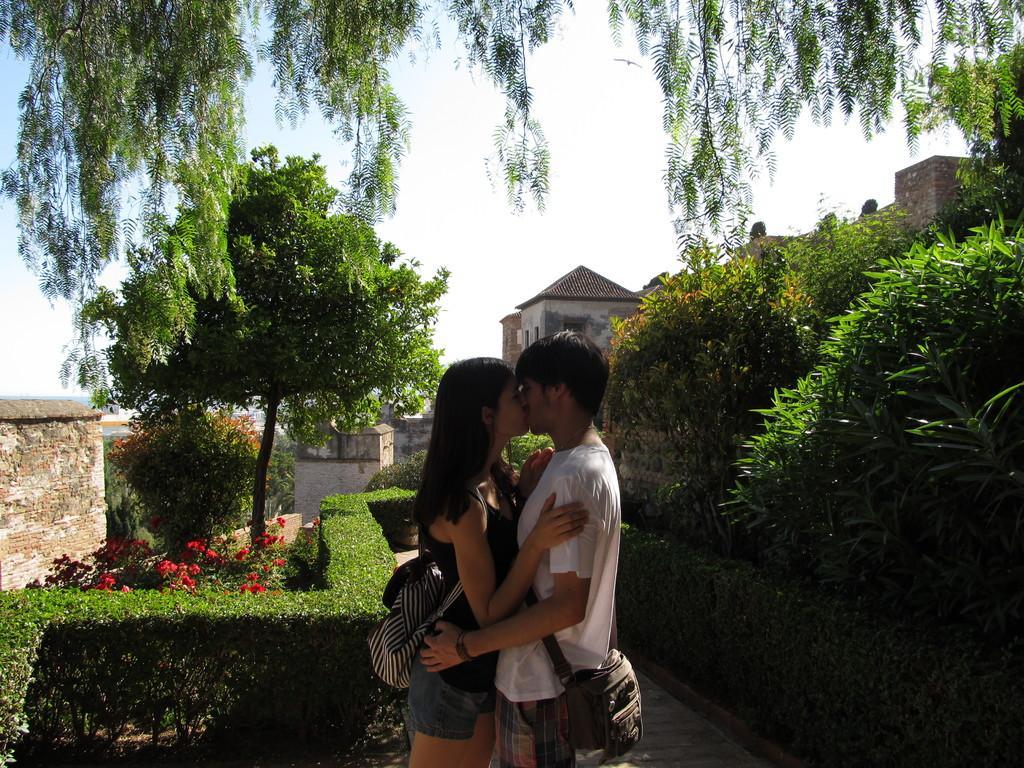Could you give a brief overview of what you see in this image? In this image in the foreground there are two persons who are standing and they are wearing bags, on the right side and left side there are some houses, plants and trees. In the background also there are some houses, at the top of the image there is sky and trees. 